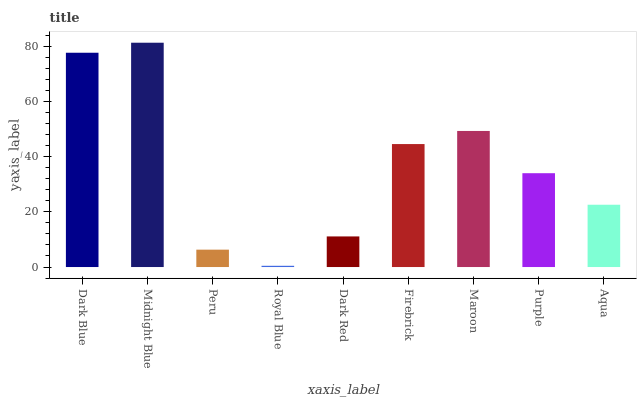Is Royal Blue the minimum?
Answer yes or no. Yes. Is Midnight Blue the maximum?
Answer yes or no. Yes. Is Peru the minimum?
Answer yes or no. No. Is Peru the maximum?
Answer yes or no. No. Is Midnight Blue greater than Peru?
Answer yes or no. Yes. Is Peru less than Midnight Blue?
Answer yes or no. Yes. Is Peru greater than Midnight Blue?
Answer yes or no. No. Is Midnight Blue less than Peru?
Answer yes or no. No. Is Purple the high median?
Answer yes or no. Yes. Is Purple the low median?
Answer yes or no. Yes. Is Peru the high median?
Answer yes or no. No. Is Dark Red the low median?
Answer yes or no. No. 